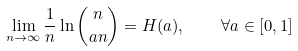<formula> <loc_0><loc_0><loc_500><loc_500>\lim _ { n \rightarrow \infty } \frac { 1 } { n } \ln \binom { n } { a n } = H ( a ) , \quad \forall a \in [ 0 , 1 ]</formula> 